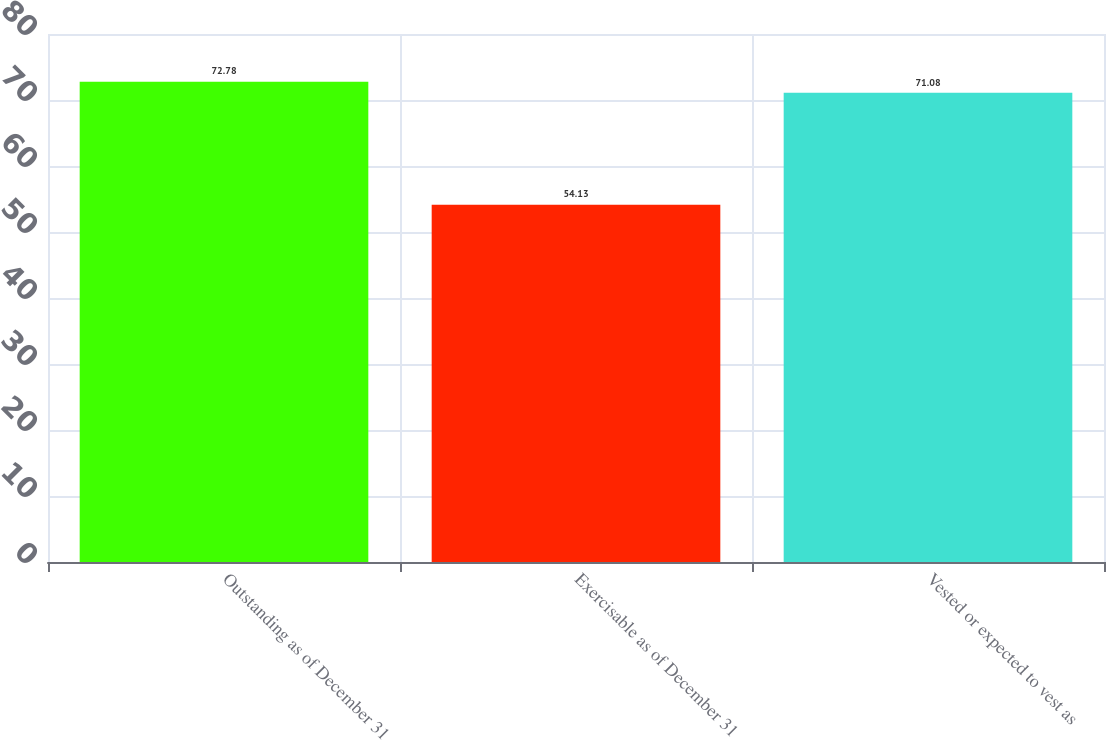<chart> <loc_0><loc_0><loc_500><loc_500><bar_chart><fcel>Outstanding as of December 31<fcel>Exercisable as of December 31<fcel>Vested or expected to vest as<nl><fcel>72.78<fcel>54.13<fcel>71.08<nl></chart> 